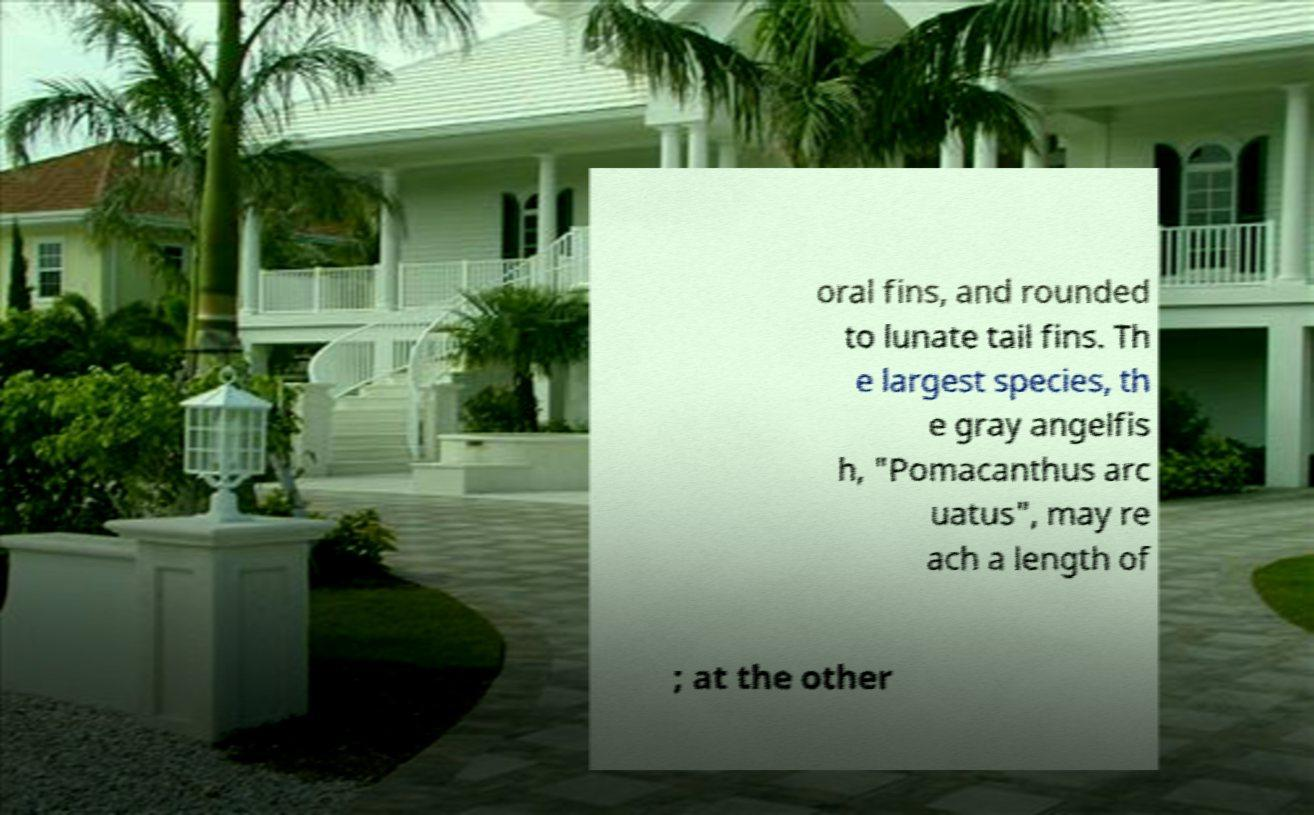What messages or text are displayed in this image? I need them in a readable, typed format. oral fins, and rounded to lunate tail fins. Th e largest species, th e gray angelfis h, "Pomacanthus arc uatus", may re ach a length of ; at the other 